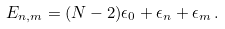<formula> <loc_0><loc_0><loc_500><loc_500>E _ { n , m } = ( N - 2 ) \epsilon _ { 0 } + \epsilon _ { n } + \epsilon _ { m } \, .</formula> 